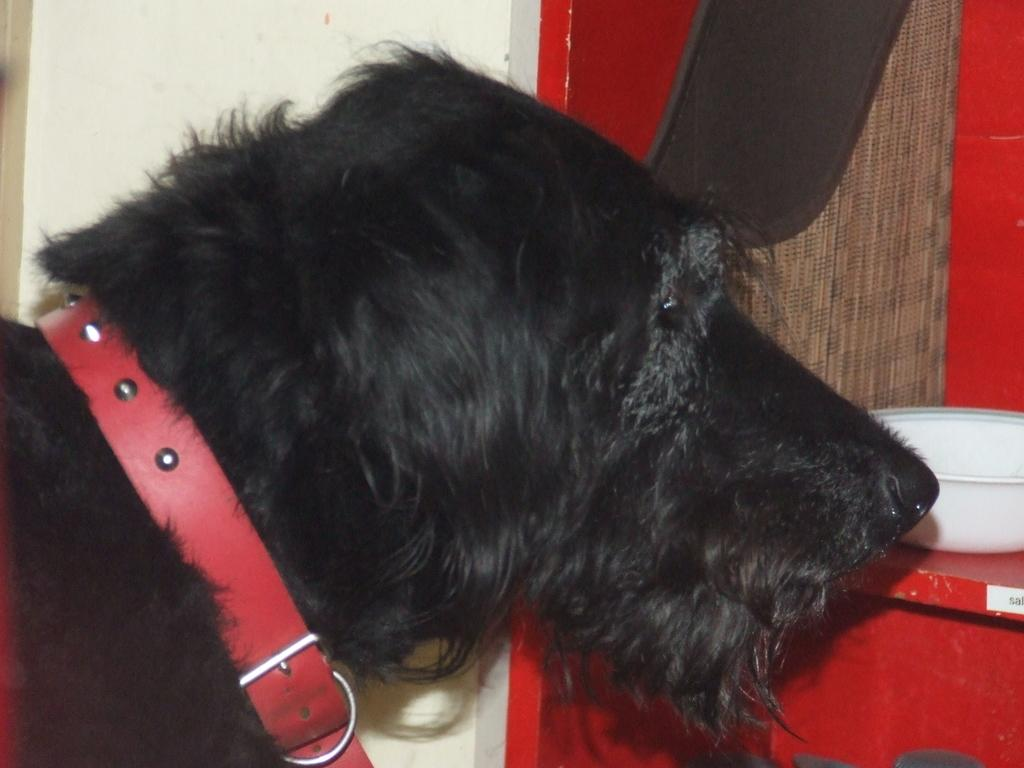What type of animal is in the image? There is a dog in the image. What is around the dog's neck? The dog has a belt around its neck. What can be seen on an object in the image? There is a bowl on an object in the image. What color is one of the objects in the image? There is a black color object in the image. What type of destruction can be seen caused by the dog in the image? There is no destruction caused by the dog in the image. What type of spark can be seen coming from the dog's collar in the image? There is no spark coming from the dog's collar in the image. 